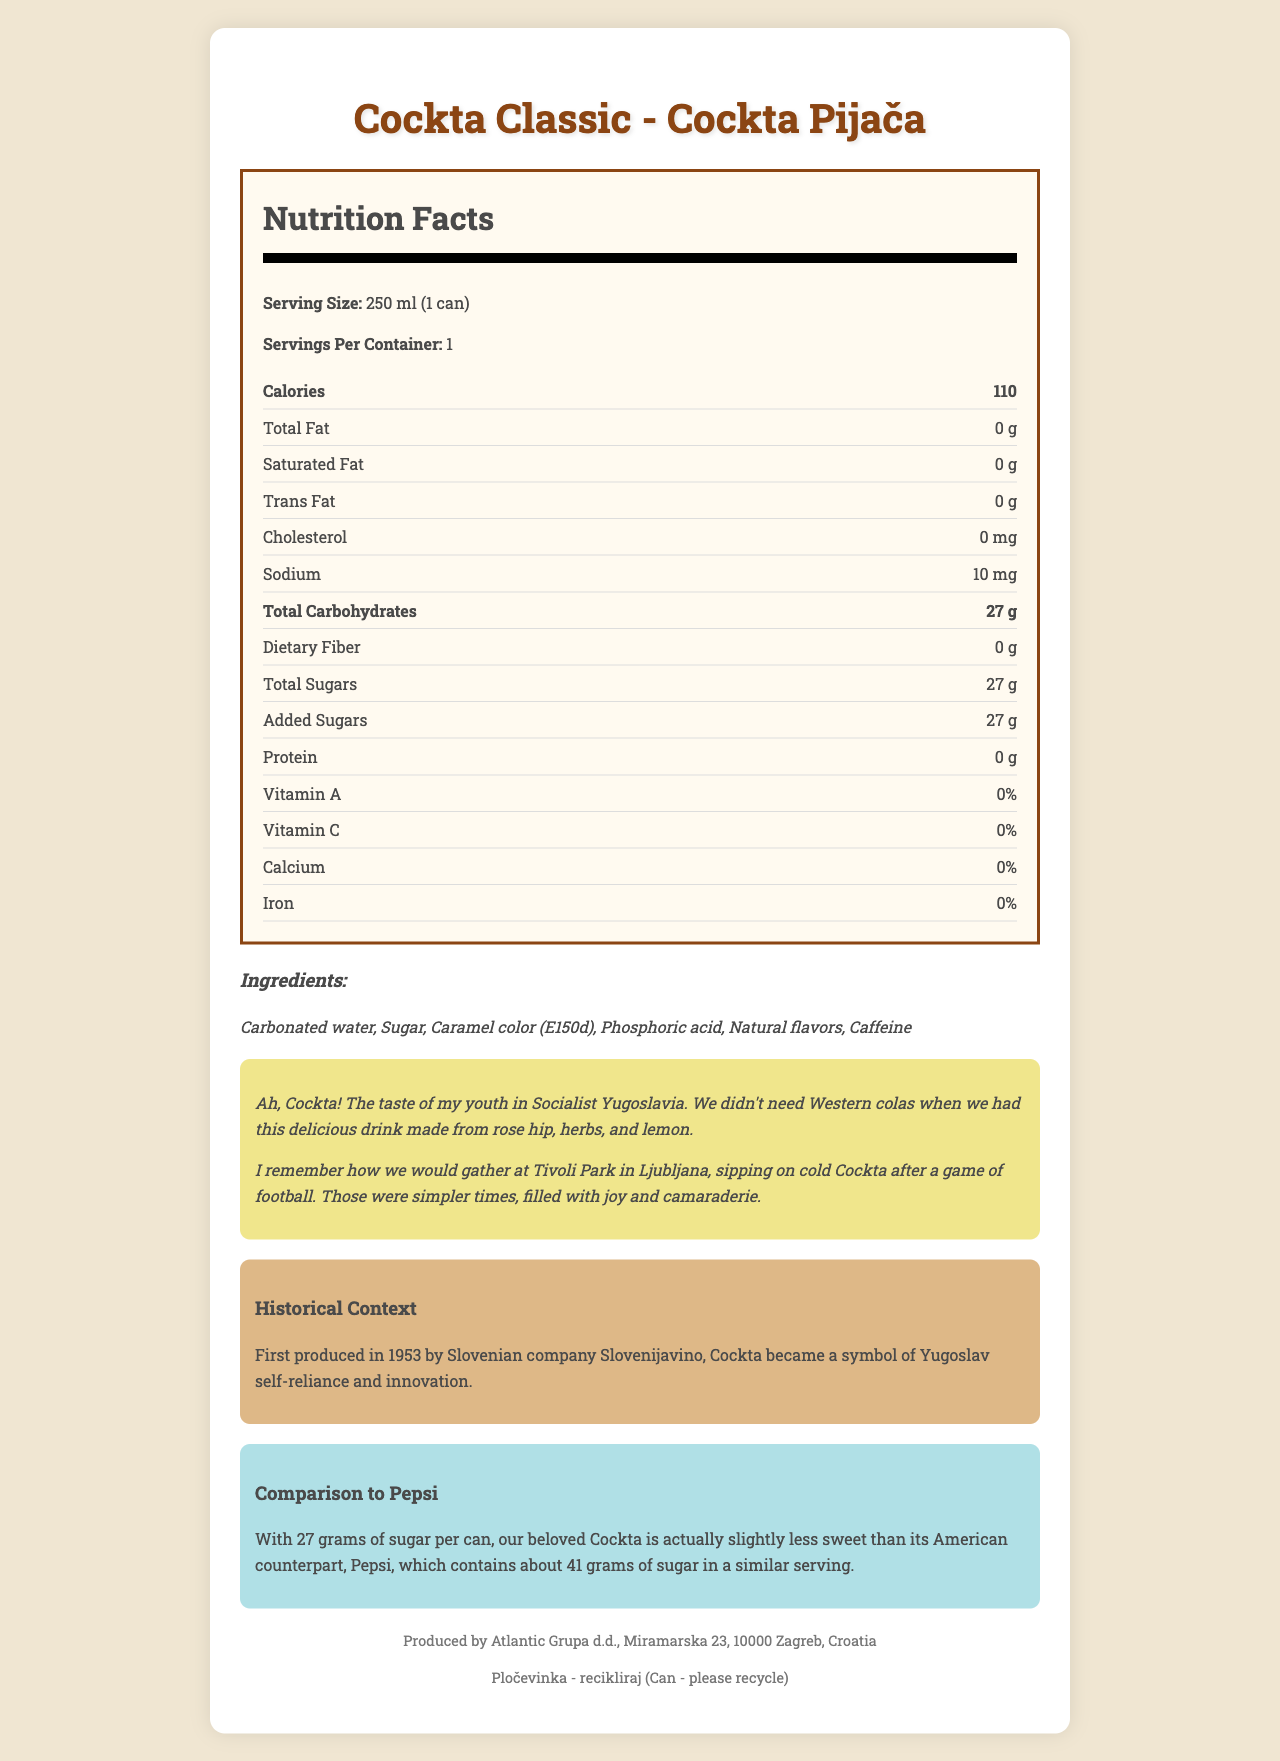what is the serving size of Cockta Classic? The serving size is stated clearly as "250 ml (1 can)" in the nutrition label part of the document.
Answer: 250 ml (1 can) how many calories are there per serving of Cockta Classic? The document shows that there are 110 calories per serving.
Answer: 110 how much sugar does one can of Cockta Classic contain? The document states "Total Sugars" as 27 grams per serving.
Answer: 27 g what are the ingredients listed for Cockta Classic? The ingredients are clearly listed in the document.
Answer: Carbonated water, Sugar, Caramel color (E150d), Phosphoric acid, Natural flavors, Caffeine who is the manufacturer of Cockta Classic? This information is found in the footer section of the document.
Answer: Atlantic Grupa d.d., Miramarska 23, 10000 Zagreb, Croatia how many milligrams of sodium are in one serving of Cockta Classic? The nutrition label section lists the sodium content as 10 mg per serving.
Answer: 10 mg what is the total carbohydrate content in a serving of Cockta Classic? The document mentions "Total Carbohydrates" as 27 grams per serving.
Answer: 27 g which nutrient has the highest percentage of daily value in Cockta Classic? A. Total Fat B. Sodium C. Total Sugars The document shows "Total Sugars: 27 g" and since there's no indication of the daily percentage values for other nutrients, sugars implicitly have the highest relevance.
Answer: C. Total Sugars which of the following vitamins are present in Cockta Classic? i. Vitamin A ii. Vitamin C iii. Both iv. None Both Vitamin A and Vitamin C are listed as 0% in the nutritional facts.
Answer: iv. None does Cockta Classic contain any protein? The protein content is listed as "0 g".
Answer: No is Cockta Classic healthier than Pepsi based solely on sugar content? Cockta has 27 grams of sugar per can, compared to Pepsi, which has about 41 grams of sugar in a similar serving; thus, Cockta is less sugary.
Answer: Yes describe the main idea of the document The document provides an overview of Cockta Classic, highlighting its nutritional facts, including calories, fats, sugars, and other contents. It lists its ingredients and gives a nostalgic view of its cultural significance along with a comparison to Pepsi. Further details about the manufacturer and recycling information are also provided.
Answer: The document provides detailed nutritional information, ingredients, historical context, and nostalgic reflections on Cockta Classic, a beloved alternative to Western colas from Yugoslavia, noting its unique taste and local significance. what year was Cockta first produced? The historical context section mentions that Cockta was first produced in 1953.
Answer: 1953 how does Cockta Classic compare to Pepsi based on the document? The comparison section clearly states the sugar content difference between Cockta and Pepsi.
Answer: Cockta Classic has 27 grams of sugar per can, which is less than Pepsi, which contains about 41 grams of sugar in a similar serving. when did the elderly Slovenian remember drinking Cockta? The nostalgic note indicates they remember sipping Cockta after football games at Tivoli Park.
Answer: After a game of football at Tivoli Park in Ljubljana A. 27g
B. 1g
C. 15g The total carbohydrates are listed as 27 grams per serving in the document.
Answer: A. 27g what flavors uniquely characterize Cockta according to the nostalgic note? The nostalgic note mentions the unique taste of Cockta made from rose hip, herbs, and lemon.
Answer: Rose hip, herbs, and lemon does the document say if Cockta Classic contains trans fats? The nutrition label states it has 0 g of trans fats.
Answer: No what were some activities associated with drinking Cockta according to the reminiscence? The reminiscence mentions gathering in Tivoli Park in Ljubljana, sipping Cockta after playing football.
Answer: Playing football with friends what is the daily value percentage of calcium in Cockta Classic? The nutrition label indicates that the daily value percentage of calcium is 0%.
Answer: 0% where is Atlantic Grupa d.d. located? The manufacturer information section provides this location information.
Answer: Miramarska 23, 10000 Zagreb, Croatia 